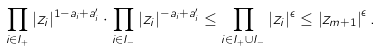<formula> <loc_0><loc_0><loc_500><loc_500>\prod _ { i \in I _ { + } } | z _ { i } | ^ { 1 - a _ { i } + a _ { i } ^ { \prime } } \cdot \prod _ { i \in I _ { - } } | z _ { i } | ^ { - a _ { i } + a _ { i } ^ { \prime } } \leq \prod _ { i \in I _ { + } \cup I _ { - } } | z _ { i } | ^ { \epsilon } \leq \left | z _ { m + 1 } \right | ^ { \epsilon } .</formula> 